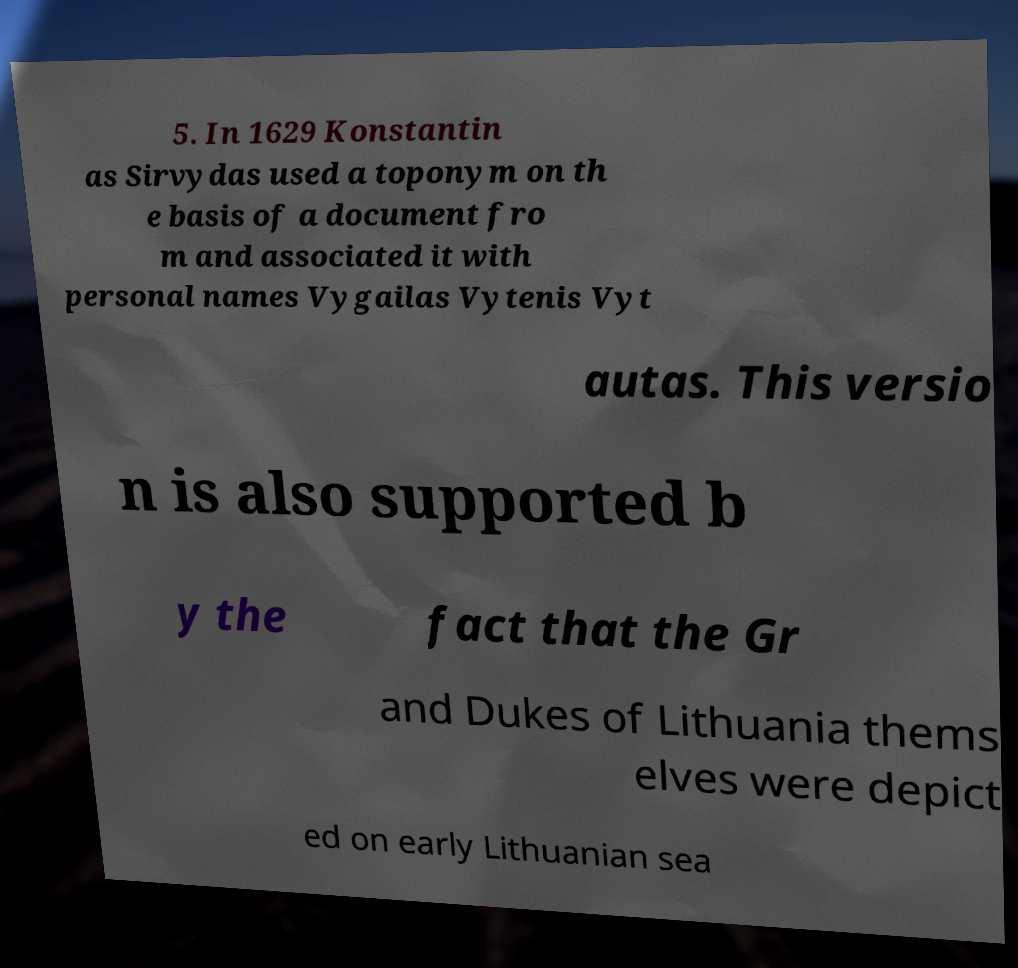There's text embedded in this image that I need extracted. Can you transcribe it verbatim? 5. In 1629 Konstantin as Sirvydas used a toponym on th e basis of a document fro m and associated it with personal names Vygailas Vytenis Vyt autas. This versio n is also supported b y the fact that the Gr and Dukes of Lithuania thems elves were depict ed on early Lithuanian sea 